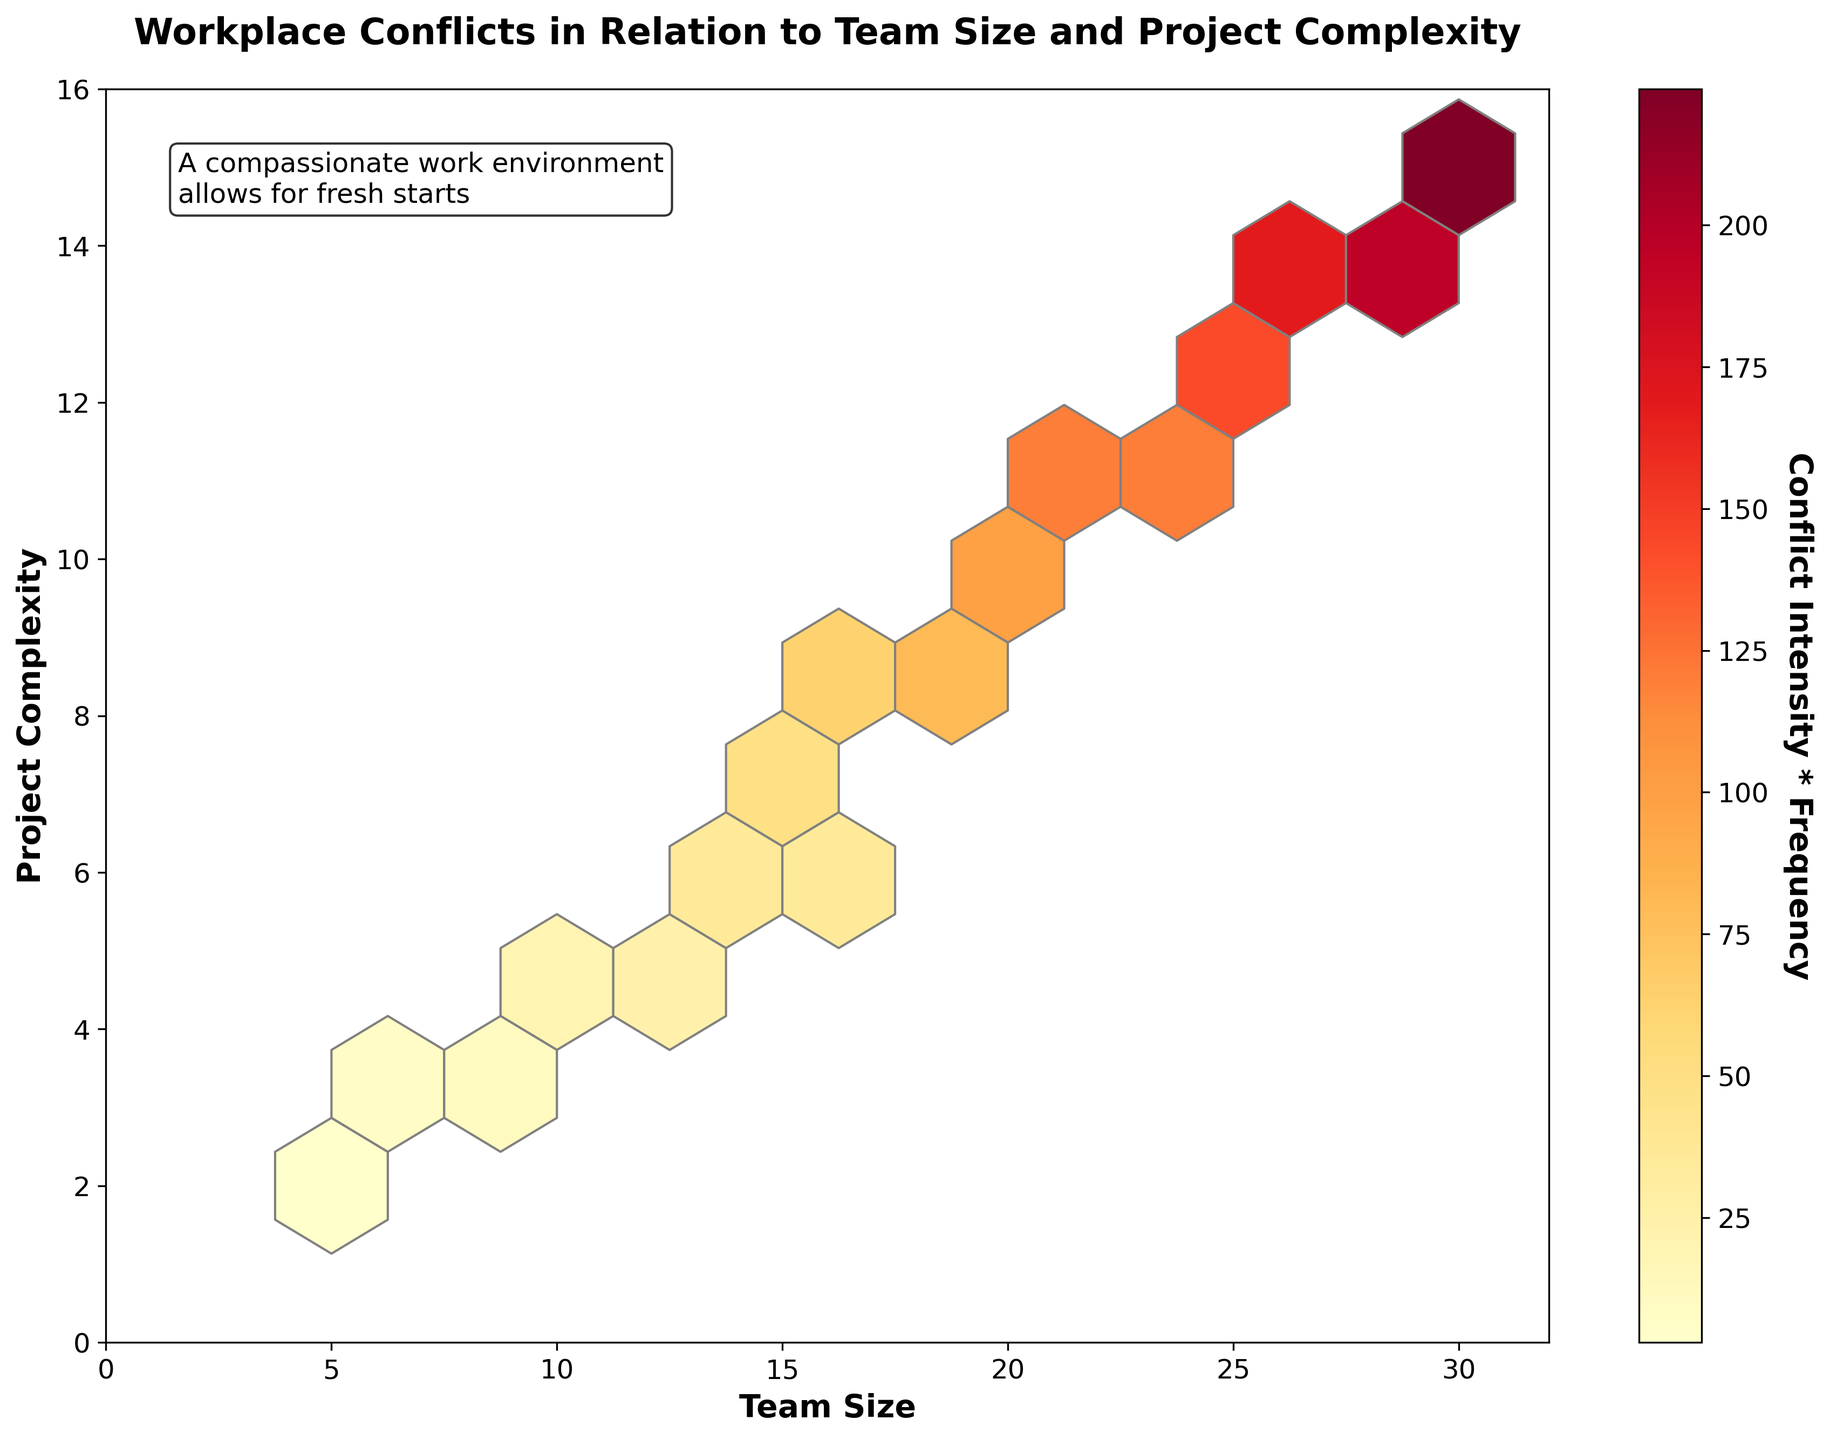What is the title of the figure? The title is usually placed at the top of the figure and is in larger, bold text to make it stand out.
Answer: Workplace Conflicts in Relation to Team Size and Project Complexity What are the labels on the x-axis and y-axis? The labels on the x-axis and y-axis are typically placed near each axis. They describe what each axis represents.
Answer: Team Size (x-axis) and Project Complexity (y-axis) What does the color bar represent? The color bar typically is located to the side of the figure and contains a label that explains what the colors mean.
Answer: Conflict Intensity * Frequency Where are the highest densities of conflicts observed in the plot? By examining the hexbin plot, the highest densities are represented by darker shades in the color range. Look for clusters with the darkest colors.
Answer: Larger team sizes and higher project complexities How does team size correlate with conflict frequency and intensity? The color intensity on the plot increases as team size and project complexity increase. By comparing these areas of high intensity, one can deduce the correlation.
Answer: Positive correlation Which team size and project complexity combination has the highest conflict intensity and frequency? Identify the hexbin with the darkest color and note its approximate position on the x and y axes.
Answer: Around team size 30 and project complexity 15 Is there a higher frequency and intensity of conflicts in smaller or larger teams? Compare the color intensities for smaller and larger teams on the x-axis while considering the y-axis as well.
Answer: Larger teams Which color palette is used for the hexbin plot? The color palette typically has a gradient and is often described in its name in the figure's legend or documentation.
Answer: YlOrRd Are there any annotations on the figure? If so, what do they convey? Check the plot for any textual notes or annotations that might provide additional context or insights.
Answer: Yes, it says "A compassionate work environment allows for fresh starts." What can we infer about conflict management in large and complex projects compared to smaller, simpler ones? Using the plot, observe the relationship between team size and complexity with conflict frequency and intensity, especially in areas of high density. This can help deduce the need for different conflict management strategies.
Answer: Larger and complex projects likely need more robust conflict management strategies How does project complexity impact conflict intensity and frequency? Observe the y-axis and how the colors change as you move from lower to higher complexities while also considering team sizes on the x-axis.
Answer: Positive correlation 